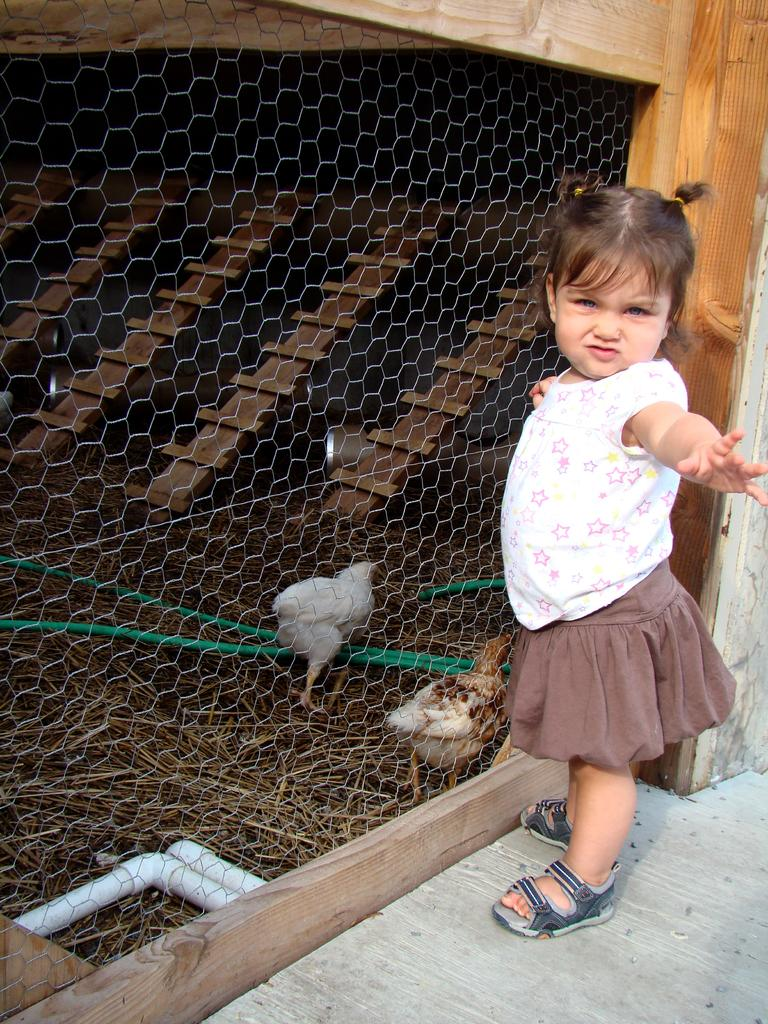What is the main subject of the image? There is a girl standing in the image. What can be seen behind the girl? There are hens behind a fence in the image. What type of vegetation is visible in the image? There is grass visible in the image. What type of structure can be seen in the image? There are pipes in the image. What is the surface on which the girl is standing? There is a floor at the bottom of the image. What type of wire can be seen connecting the hens in the image? There is no wire connecting the hens in the image; they are behind a fence. What type of trail can be seen in the image? There is no trail visible in the image. 